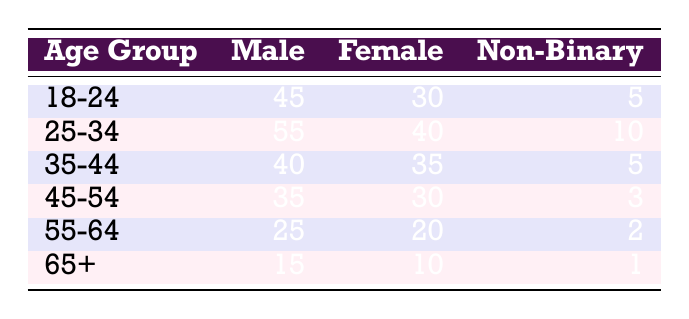What is the total number of male readers in the age group 25-34? From the table, the number of male readers in the age group 25-34 is listed as 55.
Answer: 55 What is the total number of female readers across all age groups? To find this, we sum the female readers across all age groups: 30 + 40 + 35 + 30 + 20 + 10 = 165.
Answer: 165 Is there a higher number of male readers or female readers in the age group 35-44? In the age group 35-44, there are 40 male readers and 35 female readers, showing that the number of male readers is greater.
Answer: Yes What is the age group with the highest number of non-binary readers? The number of non-binary readers by age group from the table is: 5, 10, 5, 3, 2, 1. The highest is 10, found in the age group 25-34.
Answer: 25-34 What is the average number of male readers across all age groups? To find the average, first sum the male readers: 45 + 55 + 40 + 35 + 25 + 15 = 215. Then divide by the number of age groups, which is 6, resulting in an average of 215/6 = 35.83.
Answer: 35.83 Which age group has the closest number of male and female readers? By comparing the differences: 18-24 (15), 25-34 (15), 35-44 (5), 45-54 (5), 55-64 (5), and 65+ (5). The age groups 35-44, 45-54, 55-64, and 65+ all have the closest count, with a difference of 5.
Answer: 35-44, 45-54, 55-64, 65+ Do males make up the majority of readers in the age group 45-54? For the age group 45-54, there are 35 male readers and 30 female readers, meaning males do indeed make up the majority.
Answer: Yes What is the total number of readers (male, female, and non-binary) in the age group 55-64? To obtain this, add the readers in age group 55-64: 25 (male) + 20 (female) + 2 (non-binary) = 47.
Answer: 47 